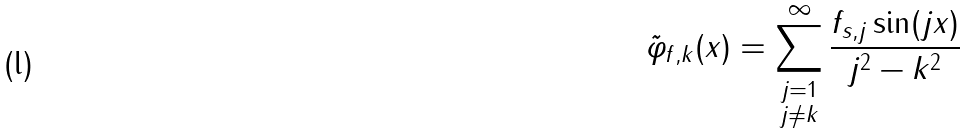Convert formula to latex. <formula><loc_0><loc_0><loc_500><loc_500>\tilde { \varphi } _ { f , k } ( x ) = \sum _ { \substack { j = 1 \\ j \neq k } } ^ { \infty } \frac { f _ { s , j } \sin ( j x ) } { j ^ { 2 } - k ^ { 2 } }</formula> 